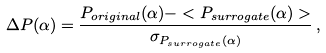<formula> <loc_0><loc_0><loc_500><loc_500>\Delta P ( \alpha ) = \frac { P _ { o r i g i n a l } ( \alpha ) - < P _ { s u r r o g a t e } ( \alpha ) > } { \sigma _ { P _ { s u r r o g a t e } ( \alpha ) } } \, ,</formula> 